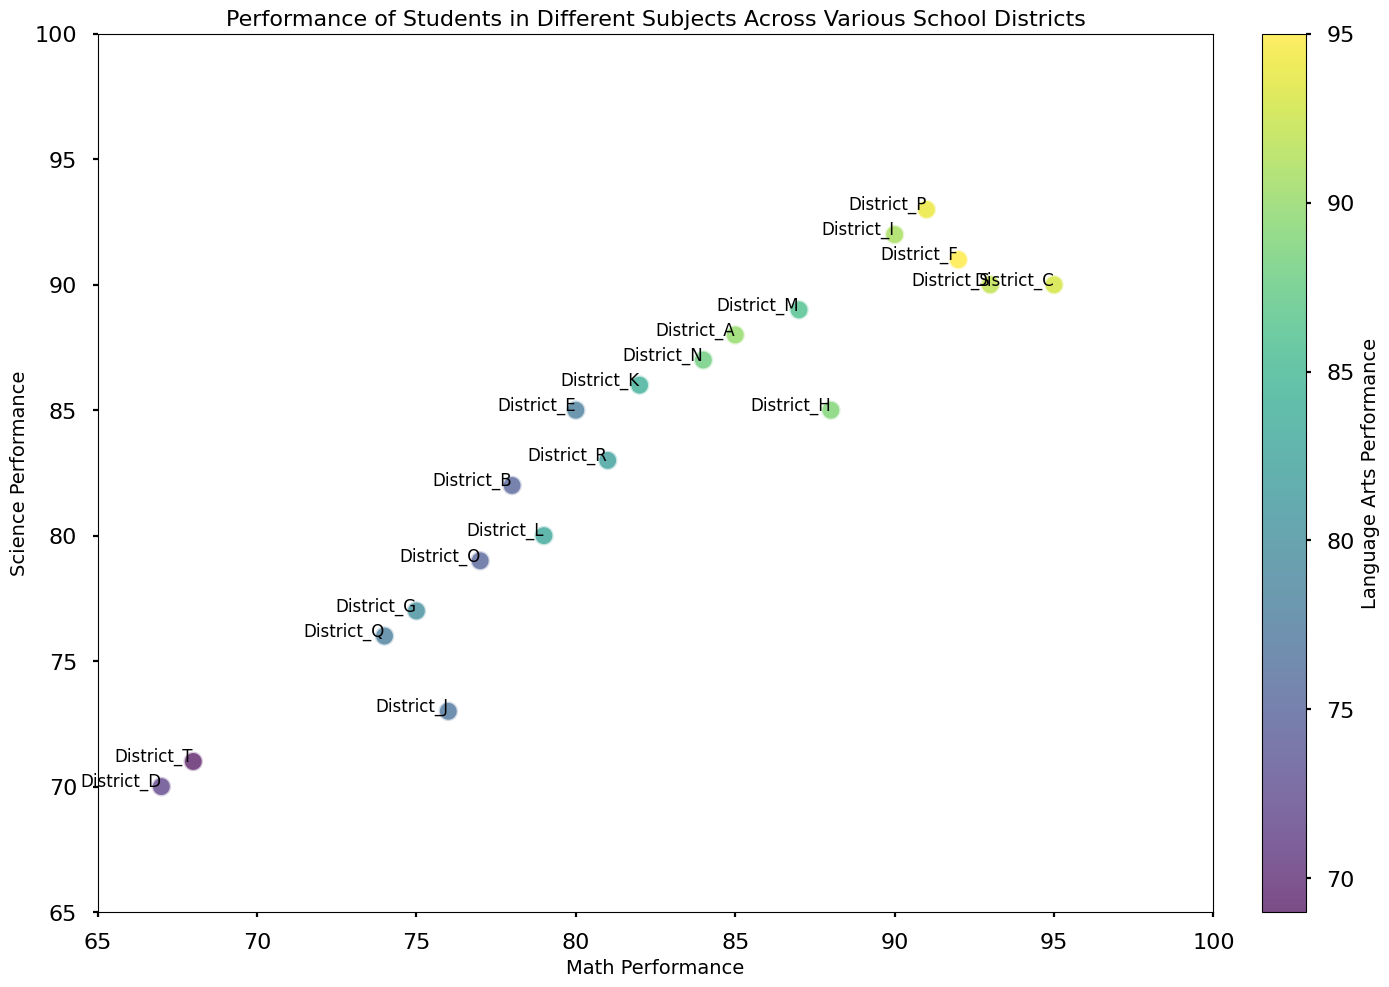Which school district has the highest performance in Math? Look at the x-axis (Math Performance) and identify the highest value. District P has the highest score of 91.
Answer: District P Which school district has the lowest Science performance? Look at the y-axis (Science Performance) and identify the lowest value. District D has the lowest score of 70.
Answer: District D Which district has a Math performance of 74? Locate the point on the x-axis nearest to 74, which is labeled as District Q.
Answer: District Q Which districts have Science performance scores of 90 or higher? Look at the y-axis for all points at or above 90. These districts are C, F, I, P, and S.
Answer: Districts C, F, I, P, S What is the average Language Arts performance score of Districts A and H? District A has a Language Arts score of 90 and District H has 89. The average is (90 + 89) / 2 = 89.5.
Answer: 89.5 Which district with a Science performance score of at least 88 has the lowest Math performance? Look at the y-axis to identify points with at least an 88 in Science, then find the one with the lowest x-axis value. District A has a Science score of 88 and the lowest Math score of 85 among those qualifying.
Answer: District A Which two school districts have nearly identical Science performance but significantly different Language Arts performance? Compare y-axis positions that are close together and examine their colors to identify notable differences. Districts R and L have very similar Science scores but District L has higher Language Arts performance.
Answer: Districts R, L If combining the Math and Science performances to find the highest combined score, which district achieves this? Sum the Math and Science scores for each district and find the highest. For District P, Math + Science = 91 + 93 = 184, which is the highest.
Answer: District P 